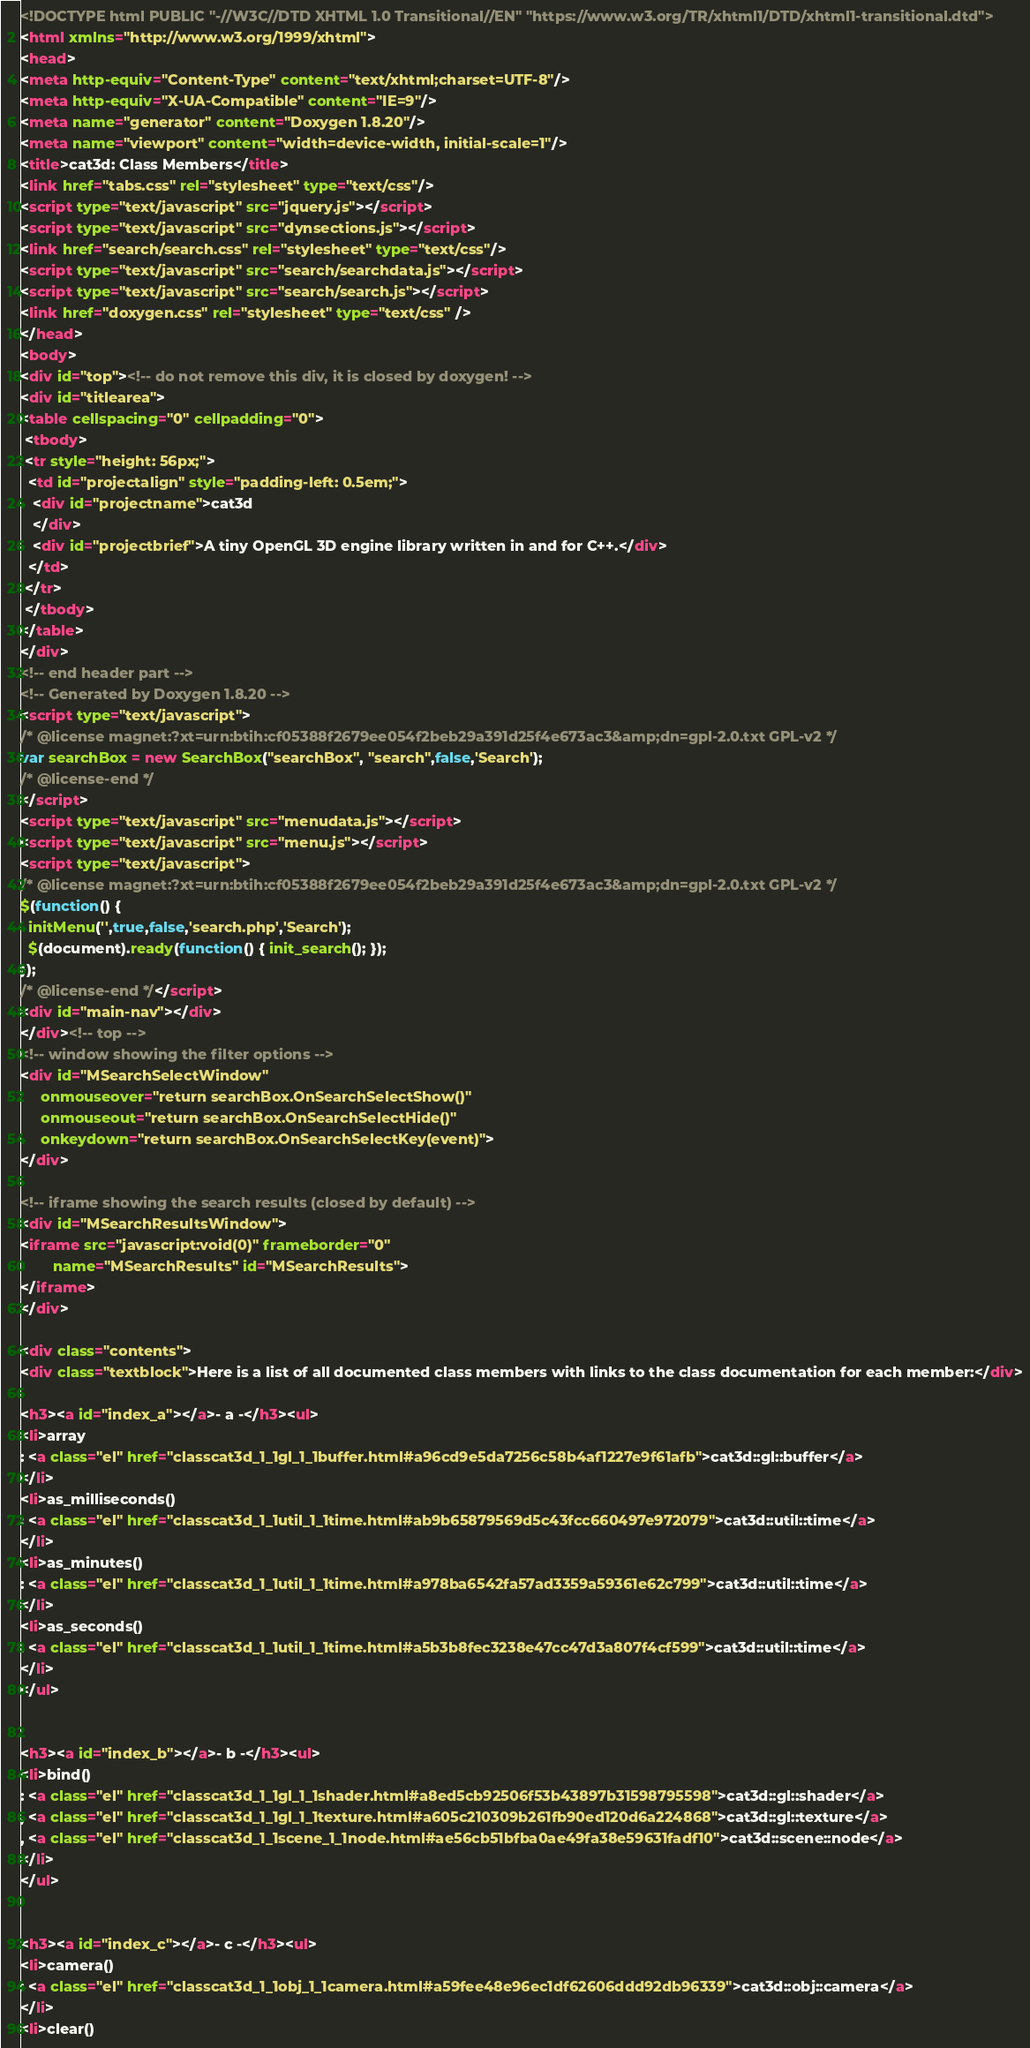Convert code to text. <code><loc_0><loc_0><loc_500><loc_500><_HTML_><!DOCTYPE html PUBLIC "-//W3C//DTD XHTML 1.0 Transitional//EN" "https://www.w3.org/TR/xhtml1/DTD/xhtml1-transitional.dtd">
<html xmlns="http://www.w3.org/1999/xhtml">
<head>
<meta http-equiv="Content-Type" content="text/xhtml;charset=UTF-8"/>
<meta http-equiv="X-UA-Compatible" content="IE=9"/>
<meta name="generator" content="Doxygen 1.8.20"/>
<meta name="viewport" content="width=device-width, initial-scale=1"/>
<title>cat3d: Class Members</title>
<link href="tabs.css" rel="stylesheet" type="text/css"/>
<script type="text/javascript" src="jquery.js"></script>
<script type="text/javascript" src="dynsections.js"></script>
<link href="search/search.css" rel="stylesheet" type="text/css"/>
<script type="text/javascript" src="search/searchdata.js"></script>
<script type="text/javascript" src="search/search.js"></script>
<link href="doxygen.css" rel="stylesheet" type="text/css" />
</head>
<body>
<div id="top"><!-- do not remove this div, it is closed by doxygen! -->
<div id="titlearea">
<table cellspacing="0" cellpadding="0">
 <tbody>
 <tr style="height: 56px;">
  <td id="projectalign" style="padding-left: 0.5em;">
   <div id="projectname">cat3d
   </div>
   <div id="projectbrief">A tiny OpenGL 3D engine library written in and for C++.</div>
  </td>
 </tr>
 </tbody>
</table>
</div>
<!-- end header part -->
<!-- Generated by Doxygen 1.8.20 -->
<script type="text/javascript">
/* @license magnet:?xt=urn:btih:cf05388f2679ee054f2beb29a391d25f4e673ac3&amp;dn=gpl-2.0.txt GPL-v2 */
var searchBox = new SearchBox("searchBox", "search",false,'Search');
/* @license-end */
</script>
<script type="text/javascript" src="menudata.js"></script>
<script type="text/javascript" src="menu.js"></script>
<script type="text/javascript">
/* @license magnet:?xt=urn:btih:cf05388f2679ee054f2beb29a391d25f4e673ac3&amp;dn=gpl-2.0.txt GPL-v2 */
$(function() {
  initMenu('',true,false,'search.php','Search');
  $(document).ready(function() { init_search(); });
});
/* @license-end */</script>
<div id="main-nav"></div>
</div><!-- top -->
<!-- window showing the filter options -->
<div id="MSearchSelectWindow"
     onmouseover="return searchBox.OnSearchSelectShow()"
     onmouseout="return searchBox.OnSearchSelectHide()"
     onkeydown="return searchBox.OnSearchSelectKey(event)">
</div>

<!-- iframe showing the search results (closed by default) -->
<div id="MSearchResultsWindow">
<iframe src="javascript:void(0)" frameborder="0" 
        name="MSearchResults" id="MSearchResults">
</iframe>
</div>

<div class="contents">
<div class="textblock">Here is a list of all documented class members with links to the class documentation for each member:</div>

<h3><a id="index_a"></a>- a -</h3><ul>
<li>array
: <a class="el" href="classcat3d_1_1gl_1_1buffer.html#a96cd9e5da7256c58b4af1227e9f61afb">cat3d::gl::buffer</a>
</li>
<li>as_milliseconds()
: <a class="el" href="classcat3d_1_1util_1_1time.html#ab9b65879569d5c43fcc660497e972079">cat3d::util::time</a>
</li>
<li>as_minutes()
: <a class="el" href="classcat3d_1_1util_1_1time.html#a978ba6542fa57ad3359a59361e62c799">cat3d::util::time</a>
</li>
<li>as_seconds()
: <a class="el" href="classcat3d_1_1util_1_1time.html#a5b3b8fec3238e47cc47d3a807f4cf599">cat3d::util::time</a>
</li>
</ul>


<h3><a id="index_b"></a>- b -</h3><ul>
<li>bind()
: <a class="el" href="classcat3d_1_1gl_1_1shader.html#a8ed5cb92506f53b43897b31598795598">cat3d::gl::shader</a>
, <a class="el" href="classcat3d_1_1gl_1_1texture.html#a605c210309b261fb90ed120d6a224868">cat3d::gl::texture</a>
, <a class="el" href="classcat3d_1_1scene_1_1node.html#ae56cb51bfba0ae49fa38e59631fadf10">cat3d::scene::node</a>
</li>
</ul>


<h3><a id="index_c"></a>- c -</h3><ul>
<li>camera()
: <a class="el" href="classcat3d_1_1obj_1_1camera.html#a59fee48e96ec1df62606ddd92db96339">cat3d::obj::camera</a>
</li>
<li>clear()</code> 